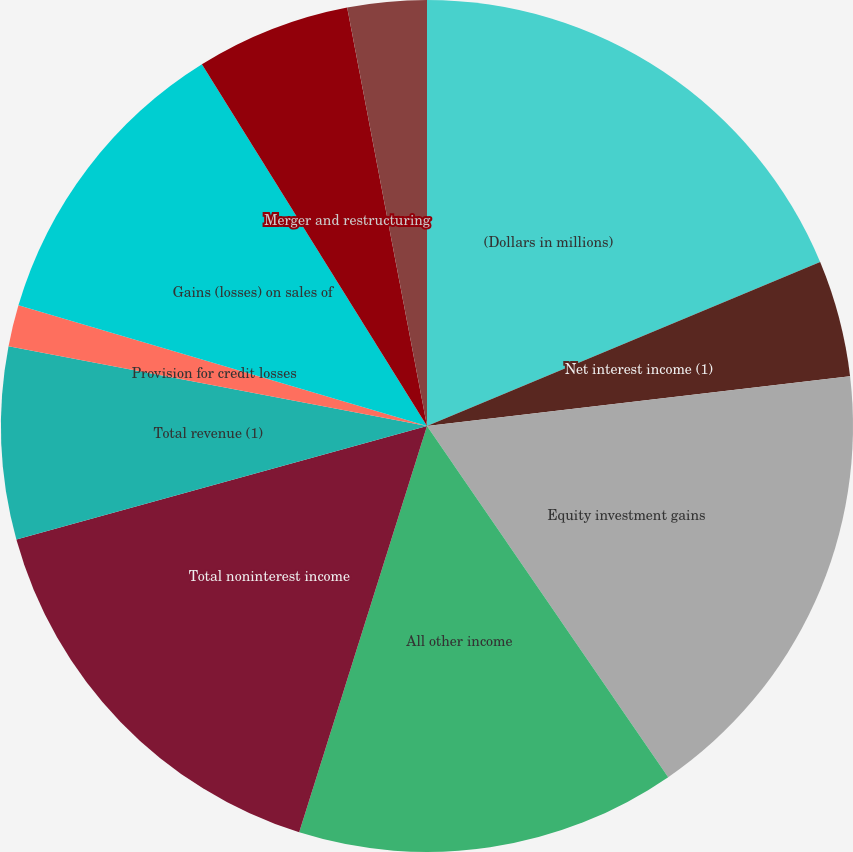Convert chart to OTSL. <chart><loc_0><loc_0><loc_500><loc_500><pie_chart><fcel>(Dollars in millions)<fcel>Net interest income (1)<fcel>Equity investment gains<fcel>All other income<fcel>Total noninterest income<fcel>Total revenue (1)<fcel>Provision for credit losses<fcel>Gains (losses) on sales of<fcel>Merger and restructuring<fcel>All other noninterest expense<nl><fcel>18.71%<fcel>4.43%<fcel>17.28%<fcel>14.43%<fcel>15.86%<fcel>7.29%<fcel>1.57%<fcel>11.57%<fcel>5.86%<fcel>3.0%<nl></chart> 